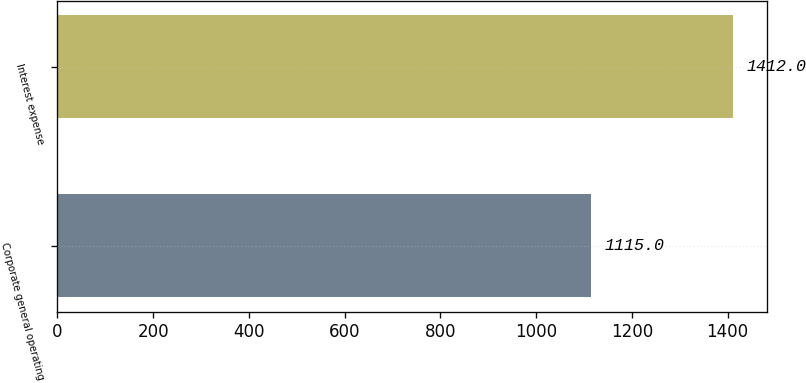Convert chart. <chart><loc_0><loc_0><loc_500><loc_500><bar_chart><fcel>Corporate general operating<fcel>Interest expense<nl><fcel>1115<fcel>1412<nl></chart> 